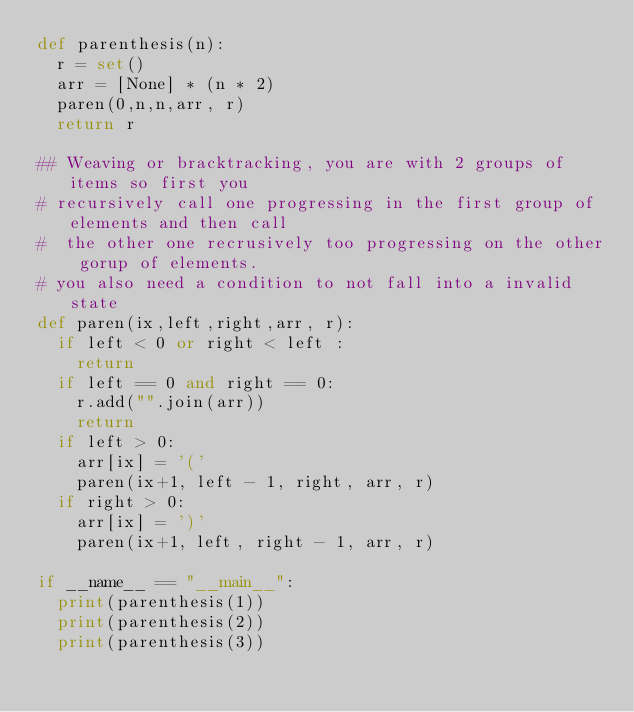<code> <loc_0><loc_0><loc_500><loc_500><_Python_>def parenthesis(n):
  r = set()
  arr = [None] * (n * 2)
  paren(0,n,n,arr, r)
  return r

## Weaving or bracktracking, you are with 2 groups of items so first you 
# recursively call one progressing in the first group of elements and then call
#  the other one recrusively too progressing on the other gorup of elements.
# you also need a condition to not fall into a invalid state
def paren(ix,left,right,arr, r):
  if left < 0 or right < left :
    return
  if left == 0 and right == 0:
    r.add("".join(arr))
    return
  if left > 0:
    arr[ix] = '('
    paren(ix+1, left - 1, right, arr, r)  
  if right > 0:
    arr[ix] = ')'
    paren(ix+1, left, right - 1, arr, r)

if __name__ == "__main__":
  print(parenthesis(1))
  print(parenthesis(2))
  print(parenthesis(3))</code> 